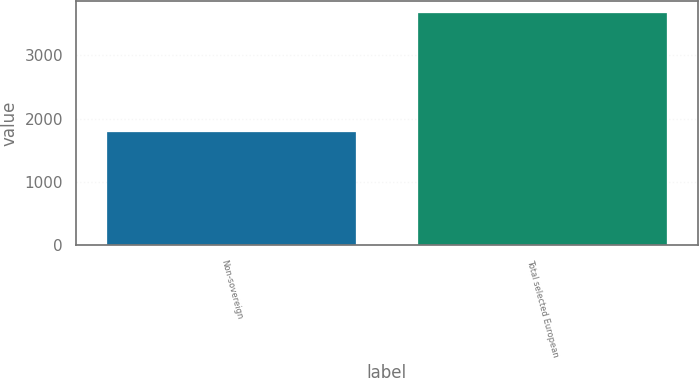<chart> <loc_0><loc_0><loc_500><loc_500><bar_chart><fcel>Non-sovereign<fcel>Total selected European<nl><fcel>1792<fcel>3668<nl></chart> 